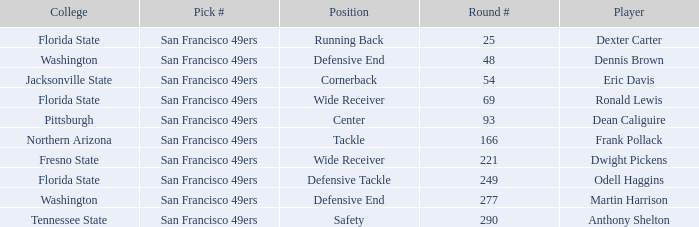Write the full table. {'header': ['College', 'Pick #', 'Position', 'Round #', 'Player'], 'rows': [['Florida State', 'San Francisco 49ers', 'Running Back', '25', 'Dexter Carter'], ['Washington', 'San Francisco 49ers', 'Defensive End', '48', 'Dennis Brown'], ['Jacksonville State', 'San Francisco 49ers', 'Cornerback', '54', 'Eric Davis'], ['Florida State', 'San Francisco 49ers', 'Wide Receiver', '69', 'Ronald Lewis'], ['Pittsburgh', 'San Francisco 49ers', 'Center', '93', 'Dean Caliguire'], ['Northern Arizona', 'San Francisco 49ers', 'Tackle', '166', 'Frank Pollack'], ['Fresno State', 'San Francisco 49ers', 'Wide Receiver', '221', 'Dwight Pickens'], ['Florida State', 'San Francisco 49ers', 'Defensive Tackle', '249', 'Odell Haggins'], ['Washington', 'San Francisco 49ers', 'Defensive End', '277', 'Martin Harrison'], ['Tennessee State', 'San Francisco 49ers', 'Safety', '290', 'Anthony Shelton']]} What is the College with a Player that is dean caliguire? Pittsburgh. 